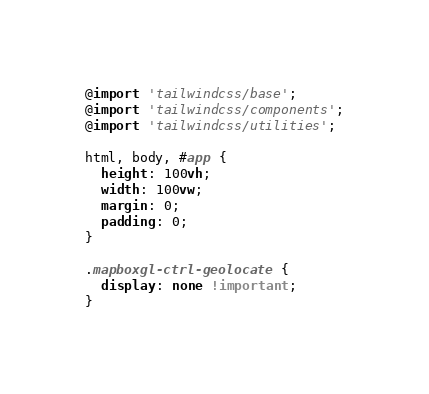<code> <loc_0><loc_0><loc_500><loc_500><_CSS_>@import 'tailwindcss/base';
@import 'tailwindcss/components';
@import 'tailwindcss/utilities';

html, body, #app {
  height: 100vh;
  width: 100vw;
  margin: 0;
  padding: 0;
}

.mapboxgl-ctrl-geolocate {
  display: none !important;
}</code> 